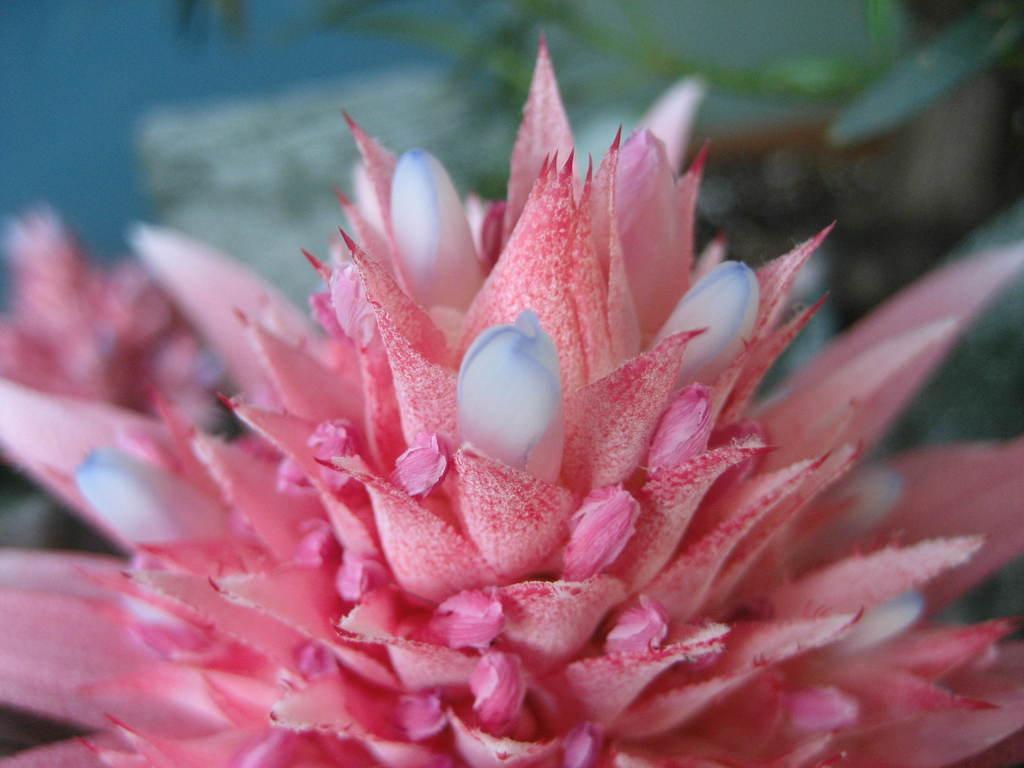Describe this image in one or two sentences. There is a pink and white color flower. In the background it is blurred. 